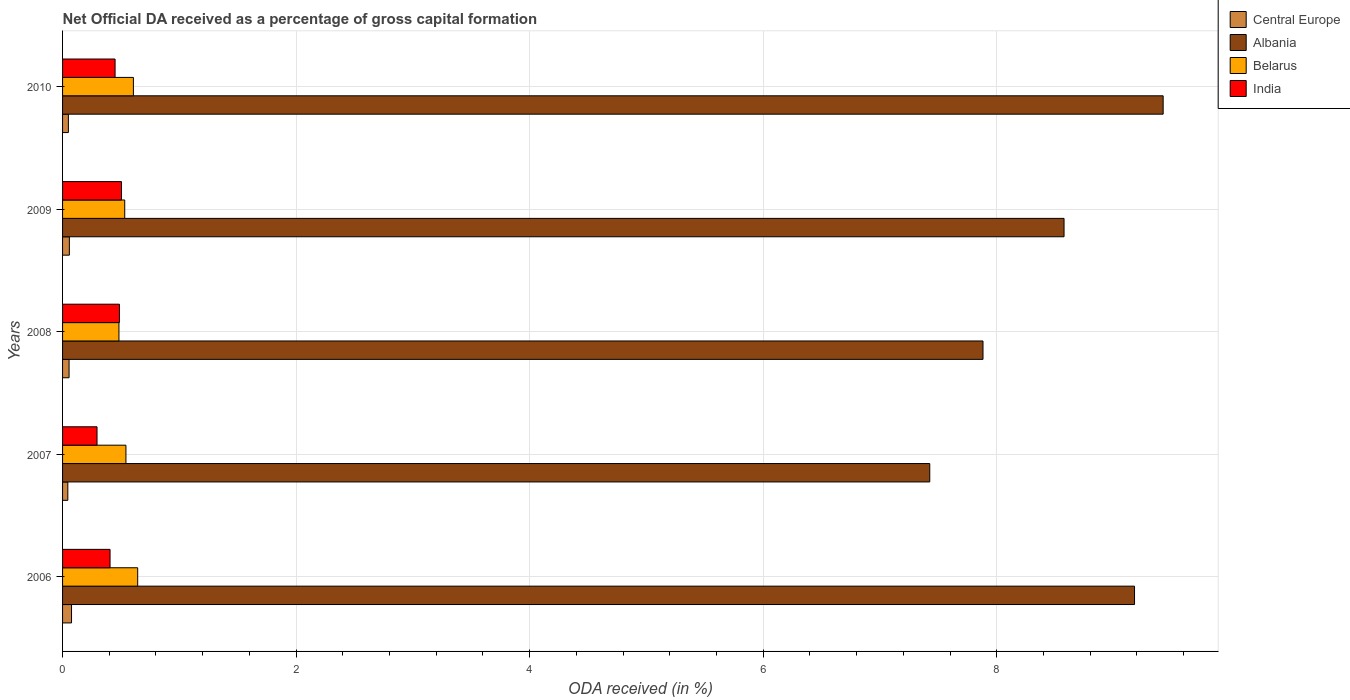Are the number of bars per tick equal to the number of legend labels?
Ensure brevity in your answer.  Yes. Are the number of bars on each tick of the Y-axis equal?
Your response must be concise. Yes. How many bars are there on the 1st tick from the top?
Your answer should be compact. 4. What is the net ODA received in Central Europe in 2007?
Give a very brief answer. 0.05. Across all years, what is the maximum net ODA received in Albania?
Your response must be concise. 9.42. Across all years, what is the minimum net ODA received in Albania?
Provide a short and direct response. 7.43. In which year was the net ODA received in Albania minimum?
Offer a very short reply. 2007. What is the total net ODA received in Belarus in the graph?
Make the answer very short. 2.81. What is the difference between the net ODA received in India in 2008 and that in 2009?
Offer a terse response. -0.02. What is the difference between the net ODA received in Albania in 2009 and the net ODA received in Belarus in 2007?
Offer a very short reply. 8.03. What is the average net ODA received in Belarus per year?
Provide a short and direct response. 0.56. In the year 2009, what is the difference between the net ODA received in Central Europe and net ODA received in India?
Provide a succinct answer. -0.45. What is the ratio of the net ODA received in Belarus in 2006 to that in 2009?
Offer a very short reply. 1.21. Is the net ODA received in India in 2007 less than that in 2009?
Your answer should be very brief. Yes. Is the difference between the net ODA received in Central Europe in 2006 and 2007 greater than the difference between the net ODA received in India in 2006 and 2007?
Your response must be concise. No. What is the difference between the highest and the second highest net ODA received in Albania?
Your response must be concise. 0.25. What is the difference between the highest and the lowest net ODA received in Central Europe?
Your answer should be compact. 0.03. In how many years, is the net ODA received in India greater than the average net ODA received in India taken over all years?
Give a very brief answer. 3. Is it the case that in every year, the sum of the net ODA received in India and net ODA received in Central Europe is greater than the sum of net ODA received in Belarus and net ODA received in Albania?
Offer a terse response. No. What does the 4th bar from the top in 2009 represents?
Offer a terse response. Central Europe. What does the 2nd bar from the bottom in 2009 represents?
Offer a terse response. Albania. Is it the case that in every year, the sum of the net ODA received in Central Europe and net ODA received in Belarus is greater than the net ODA received in Albania?
Give a very brief answer. No. How many bars are there?
Provide a short and direct response. 20. Are all the bars in the graph horizontal?
Give a very brief answer. Yes. What is the difference between two consecutive major ticks on the X-axis?
Provide a short and direct response. 2. Does the graph contain any zero values?
Ensure brevity in your answer.  No. Does the graph contain grids?
Provide a succinct answer. Yes. How many legend labels are there?
Provide a succinct answer. 4. How are the legend labels stacked?
Offer a terse response. Vertical. What is the title of the graph?
Your answer should be compact. Net Official DA received as a percentage of gross capital formation. Does "East Asia (developing only)" appear as one of the legend labels in the graph?
Offer a very short reply. No. What is the label or title of the X-axis?
Offer a very short reply. ODA received (in %). What is the label or title of the Y-axis?
Keep it short and to the point. Years. What is the ODA received (in %) in Central Europe in 2006?
Your response must be concise. 0.08. What is the ODA received (in %) of Albania in 2006?
Your response must be concise. 9.18. What is the ODA received (in %) in Belarus in 2006?
Provide a succinct answer. 0.64. What is the ODA received (in %) of India in 2006?
Make the answer very short. 0.41. What is the ODA received (in %) in Central Europe in 2007?
Your response must be concise. 0.05. What is the ODA received (in %) of Albania in 2007?
Keep it short and to the point. 7.43. What is the ODA received (in %) of Belarus in 2007?
Offer a terse response. 0.54. What is the ODA received (in %) of India in 2007?
Offer a very short reply. 0.3. What is the ODA received (in %) of Central Europe in 2008?
Make the answer very short. 0.06. What is the ODA received (in %) of Albania in 2008?
Make the answer very short. 7.88. What is the ODA received (in %) in Belarus in 2008?
Your answer should be very brief. 0.48. What is the ODA received (in %) in India in 2008?
Give a very brief answer. 0.49. What is the ODA received (in %) in Central Europe in 2009?
Your response must be concise. 0.06. What is the ODA received (in %) of Albania in 2009?
Make the answer very short. 8.58. What is the ODA received (in %) in Belarus in 2009?
Keep it short and to the point. 0.53. What is the ODA received (in %) in India in 2009?
Provide a short and direct response. 0.5. What is the ODA received (in %) in Central Europe in 2010?
Your response must be concise. 0.05. What is the ODA received (in %) of Albania in 2010?
Offer a very short reply. 9.42. What is the ODA received (in %) of Belarus in 2010?
Offer a terse response. 0.61. What is the ODA received (in %) of India in 2010?
Offer a terse response. 0.45. Across all years, what is the maximum ODA received (in %) of Central Europe?
Ensure brevity in your answer.  0.08. Across all years, what is the maximum ODA received (in %) in Albania?
Your response must be concise. 9.42. Across all years, what is the maximum ODA received (in %) in Belarus?
Offer a terse response. 0.64. Across all years, what is the maximum ODA received (in %) of India?
Your answer should be compact. 0.5. Across all years, what is the minimum ODA received (in %) in Central Europe?
Your answer should be very brief. 0.05. Across all years, what is the minimum ODA received (in %) of Albania?
Give a very brief answer. 7.43. Across all years, what is the minimum ODA received (in %) in Belarus?
Make the answer very short. 0.48. Across all years, what is the minimum ODA received (in %) of India?
Your answer should be compact. 0.3. What is the total ODA received (in %) of Central Europe in the graph?
Provide a short and direct response. 0.29. What is the total ODA received (in %) of Albania in the graph?
Keep it short and to the point. 42.49. What is the total ODA received (in %) in Belarus in the graph?
Keep it short and to the point. 2.81. What is the total ODA received (in %) of India in the graph?
Offer a very short reply. 2.14. What is the difference between the ODA received (in %) of Central Europe in 2006 and that in 2007?
Offer a terse response. 0.03. What is the difference between the ODA received (in %) in Albania in 2006 and that in 2007?
Offer a very short reply. 1.75. What is the difference between the ODA received (in %) in Belarus in 2006 and that in 2007?
Your response must be concise. 0.1. What is the difference between the ODA received (in %) in India in 2006 and that in 2007?
Make the answer very short. 0.11. What is the difference between the ODA received (in %) in Central Europe in 2006 and that in 2008?
Provide a succinct answer. 0.02. What is the difference between the ODA received (in %) in Albania in 2006 and that in 2008?
Make the answer very short. 1.3. What is the difference between the ODA received (in %) of Belarus in 2006 and that in 2008?
Keep it short and to the point. 0.16. What is the difference between the ODA received (in %) in India in 2006 and that in 2008?
Offer a very short reply. -0.08. What is the difference between the ODA received (in %) of Central Europe in 2006 and that in 2009?
Your response must be concise. 0.02. What is the difference between the ODA received (in %) in Albania in 2006 and that in 2009?
Your answer should be very brief. 0.6. What is the difference between the ODA received (in %) in Belarus in 2006 and that in 2009?
Give a very brief answer. 0.11. What is the difference between the ODA received (in %) in India in 2006 and that in 2009?
Keep it short and to the point. -0.1. What is the difference between the ODA received (in %) in Central Europe in 2006 and that in 2010?
Ensure brevity in your answer.  0.03. What is the difference between the ODA received (in %) of Albania in 2006 and that in 2010?
Ensure brevity in your answer.  -0.25. What is the difference between the ODA received (in %) of Belarus in 2006 and that in 2010?
Offer a terse response. 0.04. What is the difference between the ODA received (in %) in India in 2006 and that in 2010?
Keep it short and to the point. -0.04. What is the difference between the ODA received (in %) in Central Europe in 2007 and that in 2008?
Keep it short and to the point. -0.01. What is the difference between the ODA received (in %) in Albania in 2007 and that in 2008?
Your answer should be compact. -0.46. What is the difference between the ODA received (in %) of Belarus in 2007 and that in 2008?
Make the answer very short. 0.06. What is the difference between the ODA received (in %) of India in 2007 and that in 2008?
Your response must be concise. -0.19. What is the difference between the ODA received (in %) in Central Europe in 2007 and that in 2009?
Make the answer very short. -0.01. What is the difference between the ODA received (in %) in Albania in 2007 and that in 2009?
Your response must be concise. -1.15. What is the difference between the ODA received (in %) of Belarus in 2007 and that in 2009?
Your response must be concise. 0.01. What is the difference between the ODA received (in %) in India in 2007 and that in 2009?
Provide a short and direct response. -0.21. What is the difference between the ODA received (in %) of Central Europe in 2007 and that in 2010?
Give a very brief answer. -0. What is the difference between the ODA received (in %) of Albania in 2007 and that in 2010?
Offer a terse response. -2. What is the difference between the ODA received (in %) in Belarus in 2007 and that in 2010?
Your response must be concise. -0.06. What is the difference between the ODA received (in %) of India in 2007 and that in 2010?
Offer a very short reply. -0.15. What is the difference between the ODA received (in %) in Central Europe in 2008 and that in 2009?
Make the answer very short. -0. What is the difference between the ODA received (in %) in Albania in 2008 and that in 2009?
Ensure brevity in your answer.  -0.69. What is the difference between the ODA received (in %) in Belarus in 2008 and that in 2009?
Give a very brief answer. -0.05. What is the difference between the ODA received (in %) in India in 2008 and that in 2009?
Your answer should be compact. -0.02. What is the difference between the ODA received (in %) in Central Europe in 2008 and that in 2010?
Provide a succinct answer. 0.01. What is the difference between the ODA received (in %) in Albania in 2008 and that in 2010?
Offer a very short reply. -1.54. What is the difference between the ODA received (in %) in Belarus in 2008 and that in 2010?
Your response must be concise. -0.12. What is the difference between the ODA received (in %) in India in 2008 and that in 2010?
Offer a terse response. 0.04. What is the difference between the ODA received (in %) in Central Europe in 2009 and that in 2010?
Ensure brevity in your answer.  0.01. What is the difference between the ODA received (in %) in Albania in 2009 and that in 2010?
Offer a very short reply. -0.85. What is the difference between the ODA received (in %) in Belarus in 2009 and that in 2010?
Keep it short and to the point. -0.07. What is the difference between the ODA received (in %) of India in 2009 and that in 2010?
Offer a terse response. 0.05. What is the difference between the ODA received (in %) of Central Europe in 2006 and the ODA received (in %) of Albania in 2007?
Give a very brief answer. -7.35. What is the difference between the ODA received (in %) of Central Europe in 2006 and the ODA received (in %) of Belarus in 2007?
Your answer should be compact. -0.47. What is the difference between the ODA received (in %) in Central Europe in 2006 and the ODA received (in %) in India in 2007?
Offer a terse response. -0.22. What is the difference between the ODA received (in %) in Albania in 2006 and the ODA received (in %) in Belarus in 2007?
Your answer should be very brief. 8.64. What is the difference between the ODA received (in %) in Albania in 2006 and the ODA received (in %) in India in 2007?
Make the answer very short. 8.88. What is the difference between the ODA received (in %) of Belarus in 2006 and the ODA received (in %) of India in 2007?
Provide a succinct answer. 0.35. What is the difference between the ODA received (in %) in Central Europe in 2006 and the ODA received (in %) in Albania in 2008?
Provide a short and direct response. -7.81. What is the difference between the ODA received (in %) of Central Europe in 2006 and the ODA received (in %) of Belarus in 2008?
Provide a short and direct response. -0.41. What is the difference between the ODA received (in %) in Central Europe in 2006 and the ODA received (in %) in India in 2008?
Your response must be concise. -0.41. What is the difference between the ODA received (in %) of Albania in 2006 and the ODA received (in %) of Belarus in 2008?
Ensure brevity in your answer.  8.7. What is the difference between the ODA received (in %) of Albania in 2006 and the ODA received (in %) of India in 2008?
Give a very brief answer. 8.69. What is the difference between the ODA received (in %) of Belarus in 2006 and the ODA received (in %) of India in 2008?
Your answer should be compact. 0.16. What is the difference between the ODA received (in %) of Central Europe in 2006 and the ODA received (in %) of Albania in 2009?
Offer a terse response. -8.5. What is the difference between the ODA received (in %) of Central Europe in 2006 and the ODA received (in %) of Belarus in 2009?
Give a very brief answer. -0.46. What is the difference between the ODA received (in %) in Central Europe in 2006 and the ODA received (in %) in India in 2009?
Offer a terse response. -0.43. What is the difference between the ODA received (in %) of Albania in 2006 and the ODA received (in %) of Belarus in 2009?
Your answer should be very brief. 8.65. What is the difference between the ODA received (in %) of Albania in 2006 and the ODA received (in %) of India in 2009?
Make the answer very short. 8.68. What is the difference between the ODA received (in %) of Belarus in 2006 and the ODA received (in %) of India in 2009?
Provide a short and direct response. 0.14. What is the difference between the ODA received (in %) in Central Europe in 2006 and the ODA received (in %) in Albania in 2010?
Ensure brevity in your answer.  -9.35. What is the difference between the ODA received (in %) in Central Europe in 2006 and the ODA received (in %) in Belarus in 2010?
Provide a succinct answer. -0.53. What is the difference between the ODA received (in %) in Central Europe in 2006 and the ODA received (in %) in India in 2010?
Offer a terse response. -0.37. What is the difference between the ODA received (in %) in Albania in 2006 and the ODA received (in %) in Belarus in 2010?
Offer a very short reply. 8.57. What is the difference between the ODA received (in %) of Albania in 2006 and the ODA received (in %) of India in 2010?
Provide a short and direct response. 8.73. What is the difference between the ODA received (in %) in Belarus in 2006 and the ODA received (in %) in India in 2010?
Make the answer very short. 0.19. What is the difference between the ODA received (in %) in Central Europe in 2007 and the ODA received (in %) in Albania in 2008?
Your answer should be very brief. -7.84. What is the difference between the ODA received (in %) of Central Europe in 2007 and the ODA received (in %) of Belarus in 2008?
Give a very brief answer. -0.44. What is the difference between the ODA received (in %) of Central Europe in 2007 and the ODA received (in %) of India in 2008?
Make the answer very short. -0.44. What is the difference between the ODA received (in %) of Albania in 2007 and the ODA received (in %) of Belarus in 2008?
Keep it short and to the point. 6.94. What is the difference between the ODA received (in %) in Albania in 2007 and the ODA received (in %) in India in 2008?
Give a very brief answer. 6.94. What is the difference between the ODA received (in %) of Belarus in 2007 and the ODA received (in %) of India in 2008?
Your answer should be very brief. 0.06. What is the difference between the ODA received (in %) of Central Europe in 2007 and the ODA received (in %) of Albania in 2009?
Your response must be concise. -8.53. What is the difference between the ODA received (in %) of Central Europe in 2007 and the ODA received (in %) of Belarus in 2009?
Make the answer very short. -0.49. What is the difference between the ODA received (in %) of Central Europe in 2007 and the ODA received (in %) of India in 2009?
Your answer should be compact. -0.46. What is the difference between the ODA received (in %) of Albania in 2007 and the ODA received (in %) of Belarus in 2009?
Keep it short and to the point. 6.89. What is the difference between the ODA received (in %) of Albania in 2007 and the ODA received (in %) of India in 2009?
Offer a very short reply. 6.92. What is the difference between the ODA received (in %) in Belarus in 2007 and the ODA received (in %) in India in 2009?
Provide a succinct answer. 0.04. What is the difference between the ODA received (in %) in Central Europe in 2007 and the ODA received (in %) in Albania in 2010?
Provide a short and direct response. -9.38. What is the difference between the ODA received (in %) of Central Europe in 2007 and the ODA received (in %) of Belarus in 2010?
Ensure brevity in your answer.  -0.56. What is the difference between the ODA received (in %) in Central Europe in 2007 and the ODA received (in %) in India in 2010?
Your answer should be very brief. -0.4. What is the difference between the ODA received (in %) of Albania in 2007 and the ODA received (in %) of Belarus in 2010?
Provide a succinct answer. 6.82. What is the difference between the ODA received (in %) in Albania in 2007 and the ODA received (in %) in India in 2010?
Make the answer very short. 6.98. What is the difference between the ODA received (in %) of Belarus in 2007 and the ODA received (in %) of India in 2010?
Keep it short and to the point. 0.09. What is the difference between the ODA received (in %) in Central Europe in 2008 and the ODA received (in %) in Albania in 2009?
Ensure brevity in your answer.  -8.52. What is the difference between the ODA received (in %) of Central Europe in 2008 and the ODA received (in %) of Belarus in 2009?
Your response must be concise. -0.48. What is the difference between the ODA received (in %) in Central Europe in 2008 and the ODA received (in %) in India in 2009?
Offer a terse response. -0.45. What is the difference between the ODA received (in %) of Albania in 2008 and the ODA received (in %) of Belarus in 2009?
Offer a terse response. 7.35. What is the difference between the ODA received (in %) of Albania in 2008 and the ODA received (in %) of India in 2009?
Provide a short and direct response. 7.38. What is the difference between the ODA received (in %) in Belarus in 2008 and the ODA received (in %) in India in 2009?
Give a very brief answer. -0.02. What is the difference between the ODA received (in %) in Central Europe in 2008 and the ODA received (in %) in Albania in 2010?
Provide a short and direct response. -9.37. What is the difference between the ODA received (in %) in Central Europe in 2008 and the ODA received (in %) in Belarus in 2010?
Offer a very short reply. -0.55. What is the difference between the ODA received (in %) in Central Europe in 2008 and the ODA received (in %) in India in 2010?
Offer a very short reply. -0.39. What is the difference between the ODA received (in %) of Albania in 2008 and the ODA received (in %) of Belarus in 2010?
Your response must be concise. 7.28. What is the difference between the ODA received (in %) of Albania in 2008 and the ODA received (in %) of India in 2010?
Your response must be concise. 7.43. What is the difference between the ODA received (in %) of Belarus in 2008 and the ODA received (in %) of India in 2010?
Ensure brevity in your answer.  0.03. What is the difference between the ODA received (in %) of Central Europe in 2009 and the ODA received (in %) of Albania in 2010?
Your answer should be compact. -9.37. What is the difference between the ODA received (in %) of Central Europe in 2009 and the ODA received (in %) of Belarus in 2010?
Keep it short and to the point. -0.55. What is the difference between the ODA received (in %) in Central Europe in 2009 and the ODA received (in %) in India in 2010?
Your response must be concise. -0.39. What is the difference between the ODA received (in %) of Albania in 2009 and the ODA received (in %) of Belarus in 2010?
Your response must be concise. 7.97. What is the difference between the ODA received (in %) in Albania in 2009 and the ODA received (in %) in India in 2010?
Offer a terse response. 8.13. What is the difference between the ODA received (in %) of Belarus in 2009 and the ODA received (in %) of India in 2010?
Offer a very short reply. 0.08. What is the average ODA received (in %) in Central Europe per year?
Your answer should be very brief. 0.06. What is the average ODA received (in %) in Albania per year?
Provide a succinct answer. 8.5. What is the average ODA received (in %) in Belarus per year?
Provide a succinct answer. 0.56. What is the average ODA received (in %) in India per year?
Offer a very short reply. 0.43. In the year 2006, what is the difference between the ODA received (in %) in Central Europe and ODA received (in %) in Albania?
Your answer should be very brief. -9.1. In the year 2006, what is the difference between the ODA received (in %) of Central Europe and ODA received (in %) of Belarus?
Your response must be concise. -0.57. In the year 2006, what is the difference between the ODA received (in %) in Central Europe and ODA received (in %) in India?
Keep it short and to the point. -0.33. In the year 2006, what is the difference between the ODA received (in %) of Albania and ODA received (in %) of Belarus?
Your answer should be very brief. 8.54. In the year 2006, what is the difference between the ODA received (in %) of Albania and ODA received (in %) of India?
Provide a succinct answer. 8.77. In the year 2006, what is the difference between the ODA received (in %) of Belarus and ODA received (in %) of India?
Keep it short and to the point. 0.24. In the year 2007, what is the difference between the ODA received (in %) in Central Europe and ODA received (in %) in Albania?
Make the answer very short. -7.38. In the year 2007, what is the difference between the ODA received (in %) of Central Europe and ODA received (in %) of Belarus?
Your response must be concise. -0.5. In the year 2007, what is the difference between the ODA received (in %) in Central Europe and ODA received (in %) in India?
Keep it short and to the point. -0.25. In the year 2007, what is the difference between the ODA received (in %) of Albania and ODA received (in %) of Belarus?
Give a very brief answer. 6.88. In the year 2007, what is the difference between the ODA received (in %) in Albania and ODA received (in %) in India?
Your answer should be very brief. 7.13. In the year 2007, what is the difference between the ODA received (in %) in Belarus and ODA received (in %) in India?
Offer a terse response. 0.25. In the year 2008, what is the difference between the ODA received (in %) in Central Europe and ODA received (in %) in Albania?
Ensure brevity in your answer.  -7.83. In the year 2008, what is the difference between the ODA received (in %) in Central Europe and ODA received (in %) in Belarus?
Provide a succinct answer. -0.43. In the year 2008, what is the difference between the ODA received (in %) in Central Europe and ODA received (in %) in India?
Your answer should be compact. -0.43. In the year 2008, what is the difference between the ODA received (in %) in Albania and ODA received (in %) in Belarus?
Ensure brevity in your answer.  7.4. In the year 2008, what is the difference between the ODA received (in %) in Albania and ODA received (in %) in India?
Your answer should be compact. 7.4. In the year 2008, what is the difference between the ODA received (in %) of Belarus and ODA received (in %) of India?
Your answer should be very brief. -0. In the year 2009, what is the difference between the ODA received (in %) of Central Europe and ODA received (in %) of Albania?
Offer a very short reply. -8.52. In the year 2009, what is the difference between the ODA received (in %) of Central Europe and ODA received (in %) of Belarus?
Your answer should be compact. -0.47. In the year 2009, what is the difference between the ODA received (in %) in Central Europe and ODA received (in %) in India?
Your answer should be compact. -0.45. In the year 2009, what is the difference between the ODA received (in %) of Albania and ODA received (in %) of Belarus?
Offer a very short reply. 8.04. In the year 2009, what is the difference between the ODA received (in %) of Albania and ODA received (in %) of India?
Offer a very short reply. 8.07. In the year 2009, what is the difference between the ODA received (in %) of Belarus and ODA received (in %) of India?
Make the answer very short. 0.03. In the year 2010, what is the difference between the ODA received (in %) in Central Europe and ODA received (in %) in Albania?
Provide a succinct answer. -9.38. In the year 2010, what is the difference between the ODA received (in %) in Central Europe and ODA received (in %) in Belarus?
Keep it short and to the point. -0.56. In the year 2010, what is the difference between the ODA received (in %) in Central Europe and ODA received (in %) in India?
Provide a succinct answer. -0.4. In the year 2010, what is the difference between the ODA received (in %) in Albania and ODA received (in %) in Belarus?
Offer a terse response. 8.82. In the year 2010, what is the difference between the ODA received (in %) of Albania and ODA received (in %) of India?
Your answer should be compact. 8.98. In the year 2010, what is the difference between the ODA received (in %) of Belarus and ODA received (in %) of India?
Make the answer very short. 0.16. What is the ratio of the ODA received (in %) of Central Europe in 2006 to that in 2007?
Offer a very short reply. 1.71. What is the ratio of the ODA received (in %) in Albania in 2006 to that in 2007?
Your answer should be very brief. 1.24. What is the ratio of the ODA received (in %) of Belarus in 2006 to that in 2007?
Make the answer very short. 1.19. What is the ratio of the ODA received (in %) in India in 2006 to that in 2007?
Provide a succinct answer. 1.38. What is the ratio of the ODA received (in %) in Central Europe in 2006 to that in 2008?
Your response must be concise. 1.38. What is the ratio of the ODA received (in %) of Albania in 2006 to that in 2008?
Your answer should be compact. 1.16. What is the ratio of the ODA received (in %) of Belarus in 2006 to that in 2008?
Your answer should be very brief. 1.33. What is the ratio of the ODA received (in %) of India in 2006 to that in 2008?
Offer a very short reply. 0.84. What is the ratio of the ODA received (in %) in Central Europe in 2006 to that in 2009?
Keep it short and to the point. 1.32. What is the ratio of the ODA received (in %) in Albania in 2006 to that in 2009?
Make the answer very short. 1.07. What is the ratio of the ODA received (in %) of Belarus in 2006 to that in 2009?
Make the answer very short. 1.21. What is the ratio of the ODA received (in %) in India in 2006 to that in 2009?
Keep it short and to the point. 0.81. What is the ratio of the ODA received (in %) in Central Europe in 2006 to that in 2010?
Give a very brief answer. 1.54. What is the ratio of the ODA received (in %) in Albania in 2006 to that in 2010?
Offer a terse response. 0.97. What is the ratio of the ODA received (in %) of Belarus in 2006 to that in 2010?
Provide a succinct answer. 1.06. What is the ratio of the ODA received (in %) of India in 2006 to that in 2010?
Make the answer very short. 0.9. What is the ratio of the ODA received (in %) in Central Europe in 2007 to that in 2008?
Ensure brevity in your answer.  0.81. What is the ratio of the ODA received (in %) of Albania in 2007 to that in 2008?
Your answer should be compact. 0.94. What is the ratio of the ODA received (in %) in Belarus in 2007 to that in 2008?
Your response must be concise. 1.12. What is the ratio of the ODA received (in %) in India in 2007 to that in 2008?
Ensure brevity in your answer.  0.61. What is the ratio of the ODA received (in %) in Central Europe in 2007 to that in 2009?
Offer a very short reply. 0.77. What is the ratio of the ODA received (in %) in Albania in 2007 to that in 2009?
Offer a terse response. 0.87. What is the ratio of the ODA received (in %) of Belarus in 2007 to that in 2009?
Offer a terse response. 1.02. What is the ratio of the ODA received (in %) of India in 2007 to that in 2009?
Keep it short and to the point. 0.58. What is the ratio of the ODA received (in %) in Central Europe in 2007 to that in 2010?
Your answer should be compact. 0.9. What is the ratio of the ODA received (in %) of Albania in 2007 to that in 2010?
Make the answer very short. 0.79. What is the ratio of the ODA received (in %) in Belarus in 2007 to that in 2010?
Provide a succinct answer. 0.89. What is the ratio of the ODA received (in %) of India in 2007 to that in 2010?
Offer a very short reply. 0.66. What is the ratio of the ODA received (in %) of Central Europe in 2008 to that in 2009?
Your answer should be very brief. 0.96. What is the ratio of the ODA received (in %) in Albania in 2008 to that in 2009?
Your answer should be compact. 0.92. What is the ratio of the ODA received (in %) in Belarus in 2008 to that in 2009?
Ensure brevity in your answer.  0.91. What is the ratio of the ODA received (in %) of India in 2008 to that in 2009?
Offer a terse response. 0.96. What is the ratio of the ODA received (in %) in Central Europe in 2008 to that in 2010?
Your answer should be compact. 1.12. What is the ratio of the ODA received (in %) in Albania in 2008 to that in 2010?
Provide a short and direct response. 0.84. What is the ratio of the ODA received (in %) in Belarus in 2008 to that in 2010?
Make the answer very short. 0.8. What is the ratio of the ODA received (in %) of India in 2008 to that in 2010?
Offer a terse response. 1.08. What is the ratio of the ODA received (in %) in Central Europe in 2009 to that in 2010?
Provide a succinct answer. 1.17. What is the ratio of the ODA received (in %) in Albania in 2009 to that in 2010?
Offer a very short reply. 0.91. What is the ratio of the ODA received (in %) in Belarus in 2009 to that in 2010?
Ensure brevity in your answer.  0.88. What is the ratio of the ODA received (in %) of India in 2009 to that in 2010?
Your answer should be compact. 1.12. What is the difference between the highest and the second highest ODA received (in %) in Central Europe?
Make the answer very short. 0.02. What is the difference between the highest and the second highest ODA received (in %) in Albania?
Your answer should be very brief. 0.25. What is the difference between the highest and the second highest ODA received (in %) of Belarus?
Give a very brief answer. 0.04. What is the difference between the highest and the second highest ODA received (in %) of India?
Your response must be concise. 0.02. What is the difference between the highest and the lowest ODA received (in %) of Central Europe?
Provide a succinct answer. 0.03. What is the difference between the highest and the lowest ODA received (in %) of Albania?
Ensure brevity in your answer.  2. What is the difference between the highest and the lowest ODA received (in %) of Belarus?
Your answer should be very brief. 0.16. What is the difference between the highest and the lowest ODA received (in %) in India?
Offer a terse response. 0.21. 